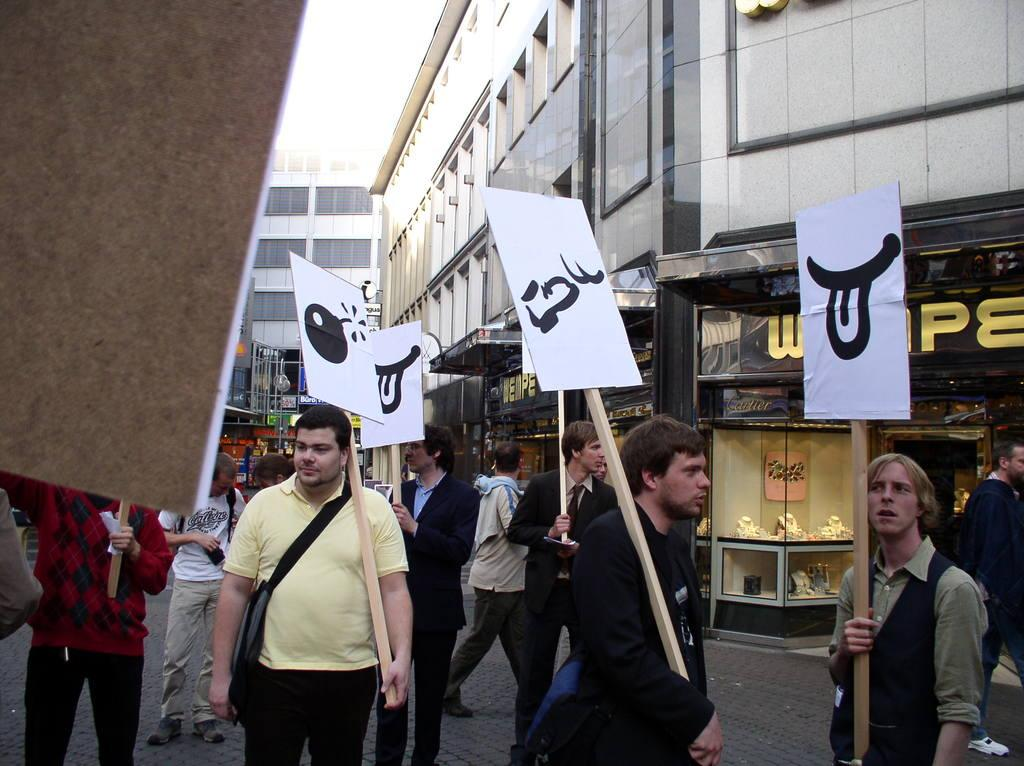What type of structures are visible in the image? There are buildings in the image. Are there any living beings present in the image? Yes, there are people in the image. What are the people holding in their hands? The people are holding boards in their hands. What type of crime is being committed by the people holding the boards in the image? There is no indication of any crime being committed in the image; the people are simply holding boards in their hands. 